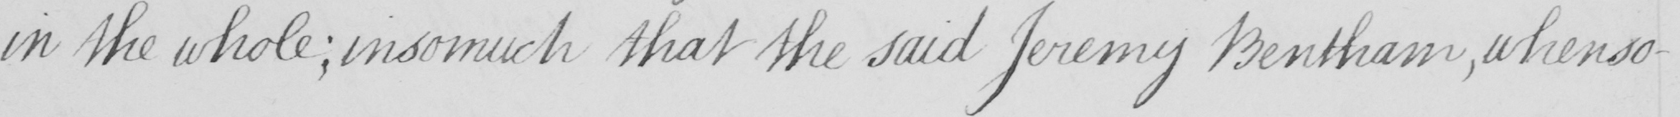What is written in this line of handwriting? in the whole  ; insomuch that the said Jeremy Bentham , whenso- 